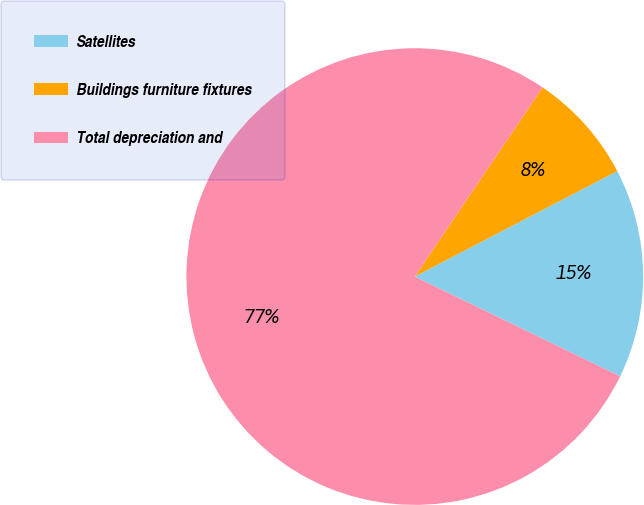<chart> <loc_0><loc_0><loc_500><loc_500><pie_chart><fcel>Satellites<fcel>Buildings furniture fixtures<fcel>Total depreciation and<nl><fcel>14.84%<fcel>7.9%<fcel>77.26%<nl></chart> 